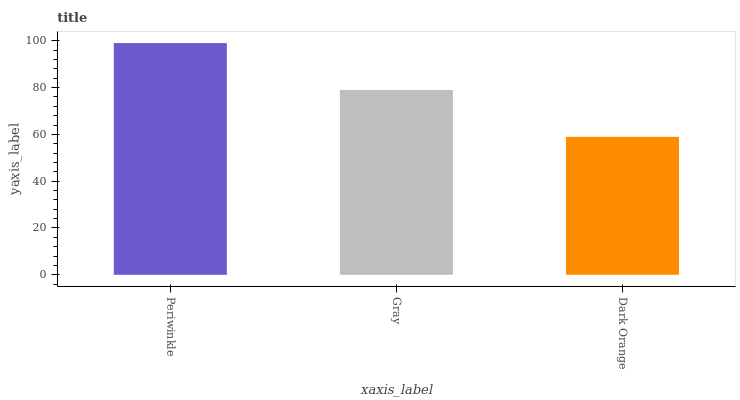Is Dark Orange the minimum?
Answer yes or no. Yes. Is Periwinkle the maximum?
Answer yes or no. Yes. Is Gray the minimum?
Answer yes or no. No. Is Gray the maximum?
Answer yes or no. No. Is Periwinkle greater than Gray?
Answer yes or no. Yes. Is Gray less than Periwinkle?
Answer yes or no. Yes. Is Gray greater than Periwinkle?
Answer yes or no. No. Is Periwinkle less than Gray?
Answer yes or no. No. Is Gray the high median?
Answer yes or no. Yes. Is Gray the low median?
Answer yes or no. Yes. Is Periwinkle the high median?
Answer yes or no. No. Is Periwinkle the low median?
Answer yes or no. No. 